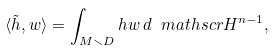Convert formula to latex. <formula><loc_0><loc_0><loc_500><loc_500>\langle \tilde { h } , w \rangle = \int _ { M \smallsetminus D } h w \, d \ m a t h s c r { H } ^ { n - 1 } ,</formula> 